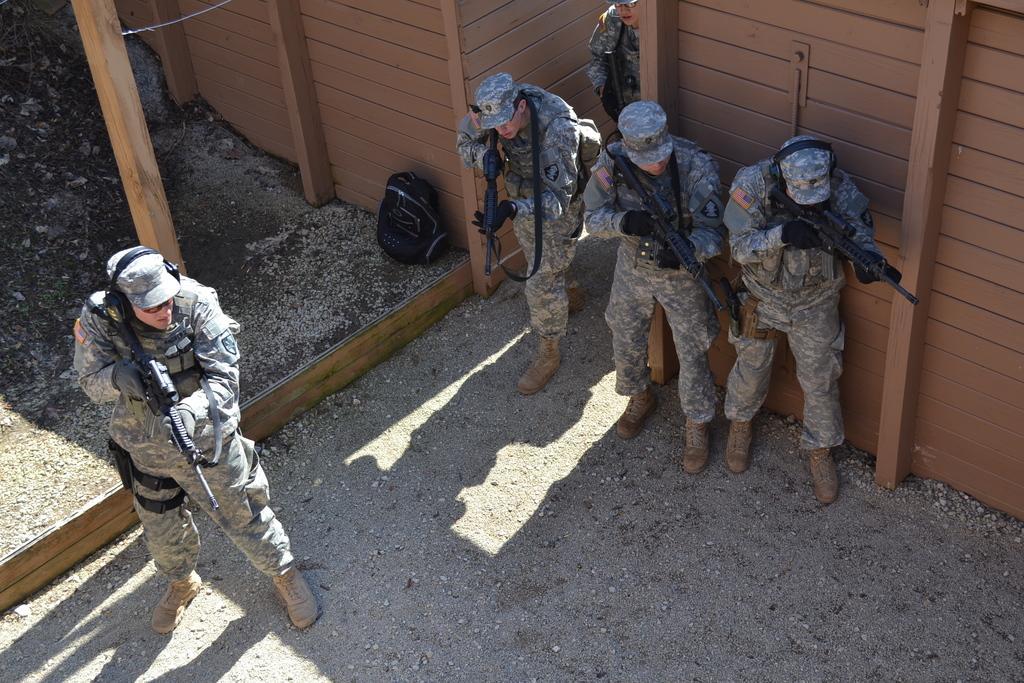Please provide a concise description of this image. In this image we can see some people standing on the land holding the guns. We can also see a bag on the land and a wooden wall. 